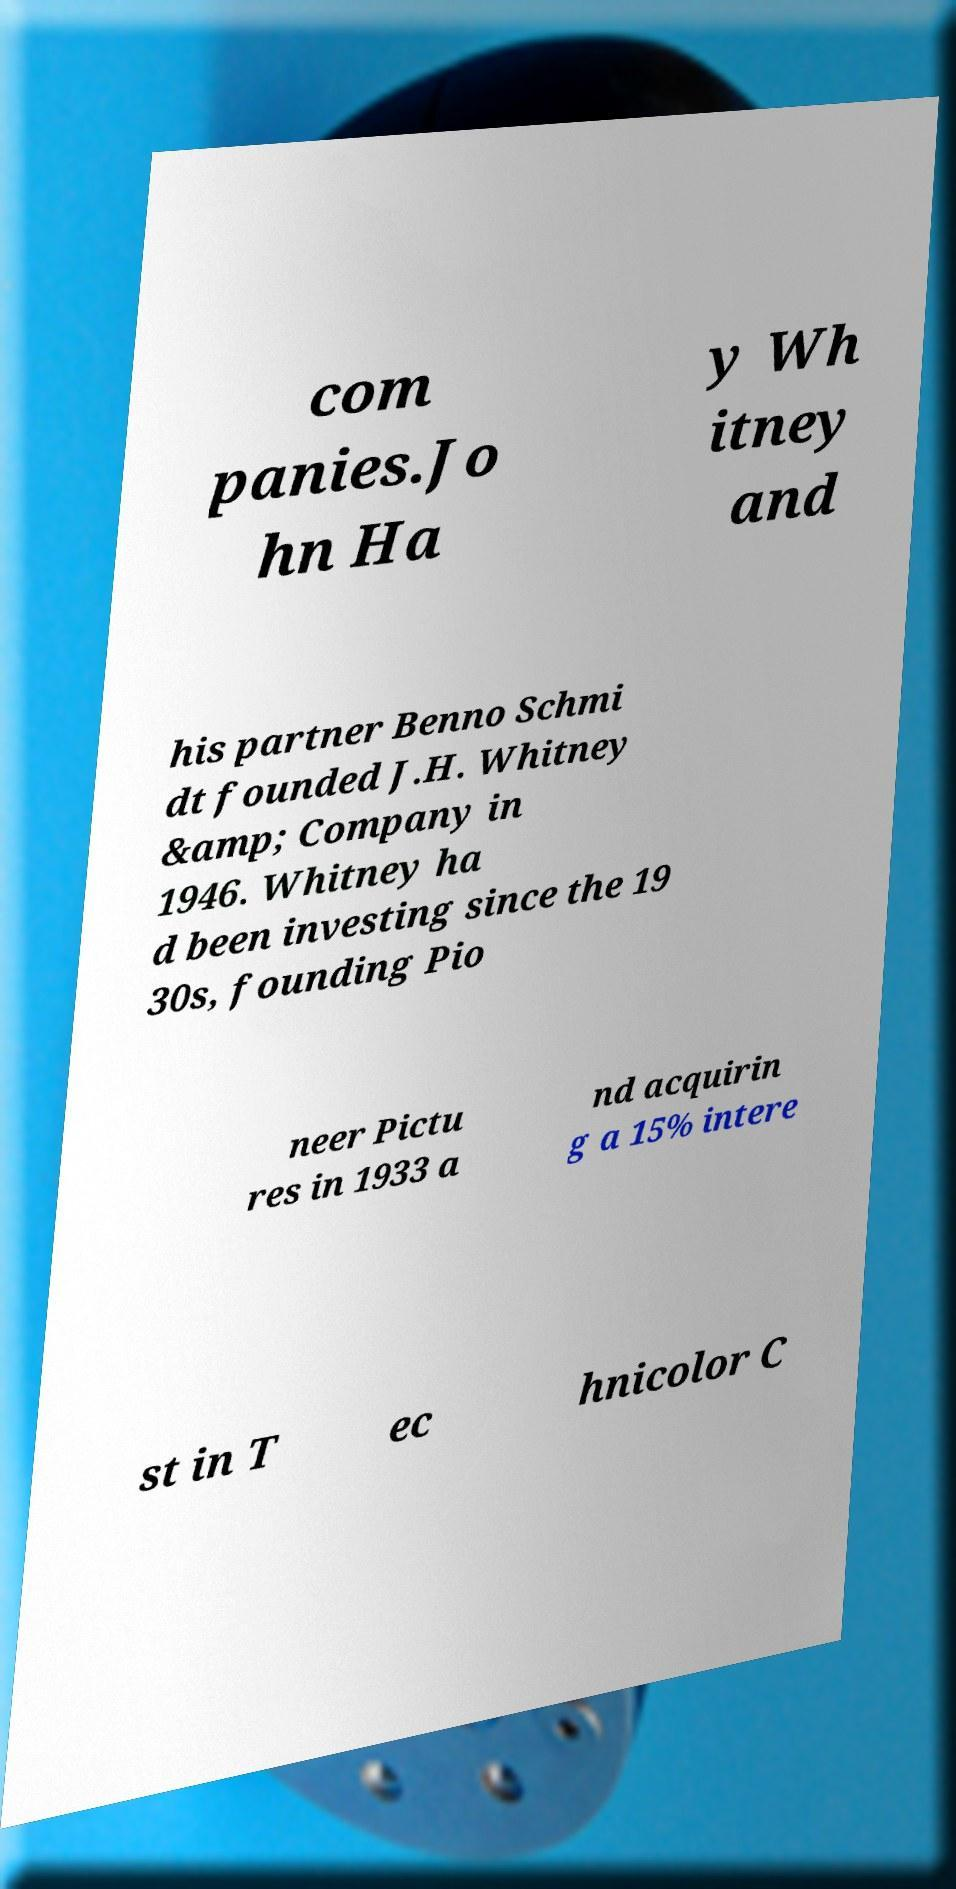Could you extract and type out the text from this image? com panies.Jo hn Ha y Wh itney and his partner Benno Schmi dt founded J.H. Whitney &amp; Company in 1946. Whitney ha d been investing since the 19 30s, founding Pio neer Pictu res in 1933 a nd acquirin g a 15% intere st in T ec hnicolor C 